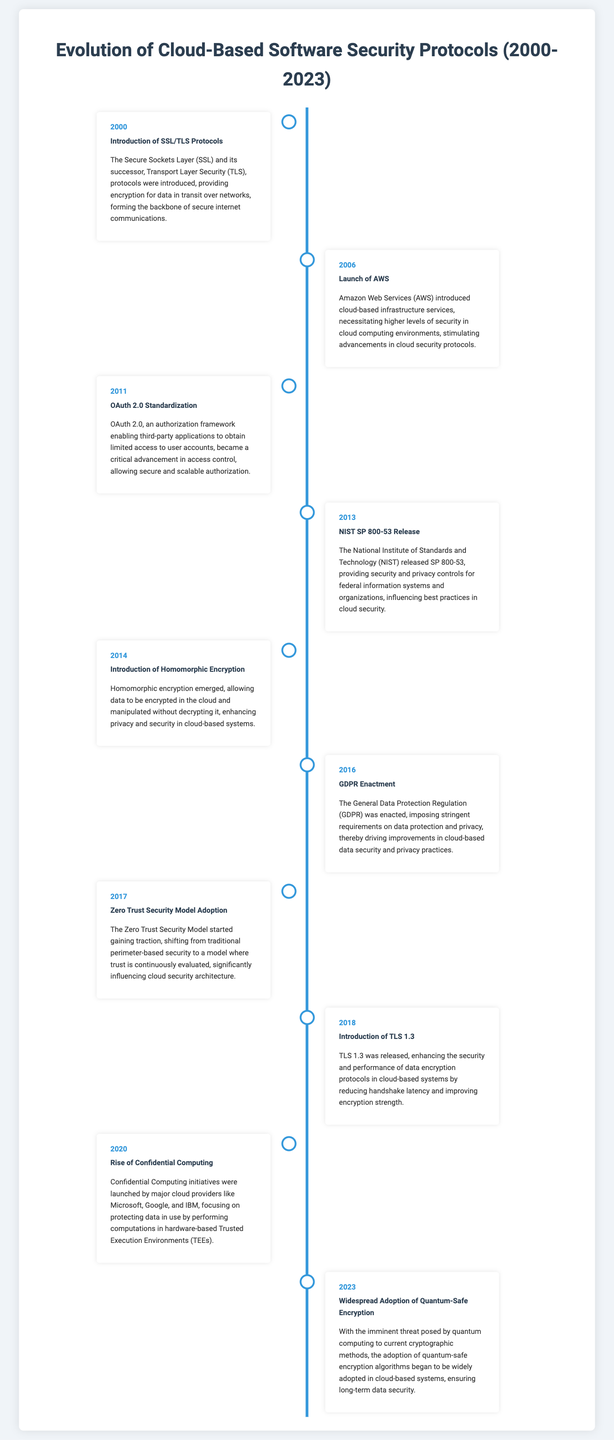what year was TLS 1.3 introduced? The year TLS 1.3 was released is noted in the timeline provided, which indicates major advancements in encryption protocols for cloud-based systems.
Answer: 2018 what significant regulation was enacted in 2016? The timeline mentions the enactment of GDPR, which is a crucial regulation impacting data privacy and protection, especially in cloud environments.
Answer: GDPR which protocol became standardized in 2011? The timeline highlights OAuth 2.0 as a critical authorization framework that was standardized in 2011 to improve access control in cloud systems.
Answer: OAuth 2.0 what security model gained popularity in 2017? The timeline indicates that the Zero Trust Security Model started gaining traction in 2017, which significantly influenced cloud security architecture.
Answer: Zero Trust Security Model what is the key feature of homomorphic encryption? The event in 2014 outlines that homomorphic encryption allows data to be manipulated while encrypted, enhancing privacy and security in cloud systems.
Answer: Data manipulation without decryption which milestone highlighted a need for higher security levels in cloud computing? The launch of AWS in 2006 is noted as a key milestone that drove advancements in cloud security protocols due to the introduction of cloud-based infrastructure services.
Answer: Launch of AWS how did GDPR affect cloud security practices? The enactment of GDPR imposed stringent requirements on data protection and privacy, influencing best practices in cloud security as noted in the timeline.
Answer: Improved data security practices what was a main focus of the Confidential Computing initiatives introduced in 2020? The timeline mentions Confidential Computing focused on protecting data in use through hardware-based Trusted Execution Environments, reflecting a significant advancement in cloud security.
Answer: Protecting data in use what is a primary contribution of NIST SP 800-53 released in 2013? NIST SP 800-53 provided security and privacy controls, influencing best practices in cloud security as highlighted in that year’s milestone.
Answer: Security and privacy controls 